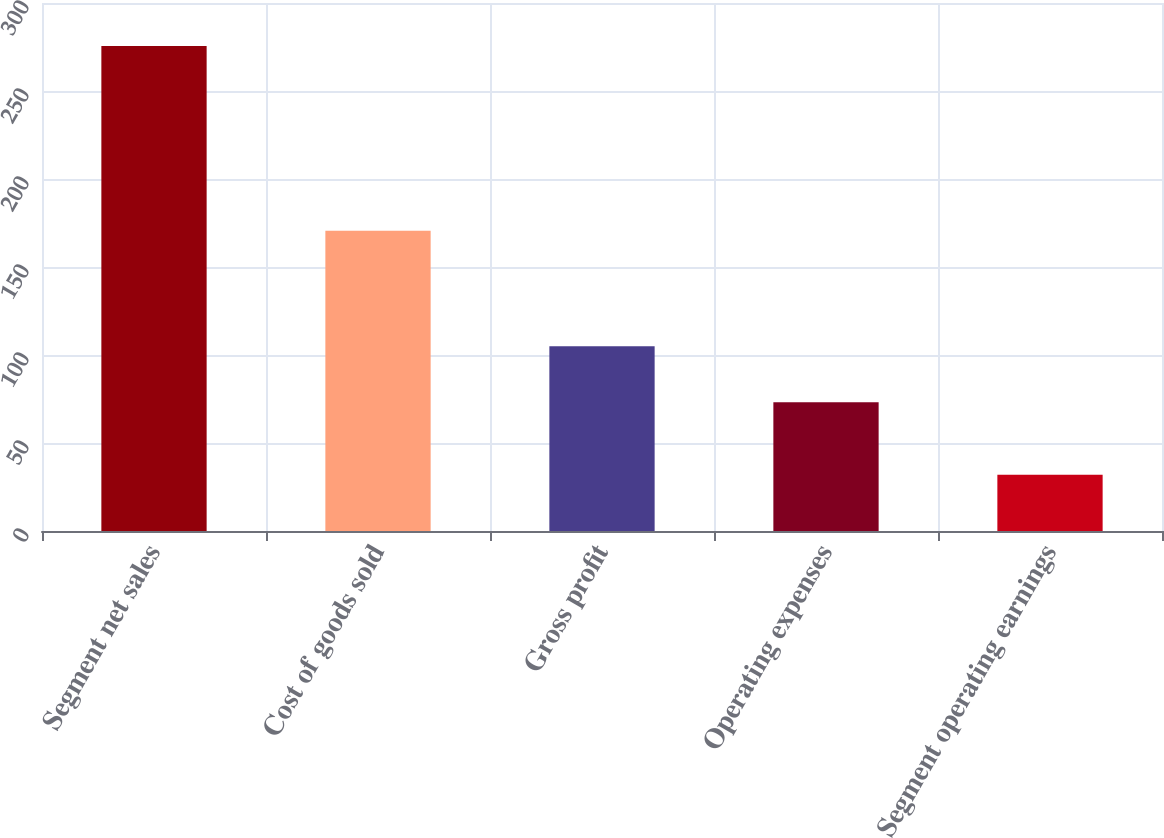<chart> <loc_0><loc_0><loc_500><loc_500><bar_chart><fcel>Segment net sales<fcel>Cost of goods sold<fcel>Gross profit<fcel>Operating expenses<fcel>Segment operating earnings<nl><fcel>275.6<fcel>170.6<fcel>105<fcel>73.1<fcel>31.9<nl></chart> 